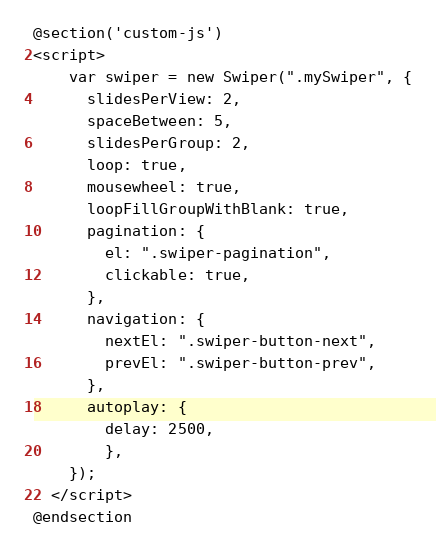<code> <loc_0><loc_0><loc_500><loc_500><_PHP_>@section('custom-js')
<script>
    var swiper = new Swiper(".mySwiper", {
      slidesPerView: 2,
      spaceBetween: 5,
      slidesPerGroup: 2,
      loop: true,
      mousewheel: true,
      loopFillGroupWithBlank: true,
      pagination: {
        el: ".swiper-pagination",
        clickable: true,
      },
      navigation: {
        nextEl: ".swiper-button-next",
        prevEl: ".swiper-button-prev",
      },
      autoplay: {
        delay: 2500,
        },
    });
  </script>
@endsection</code> 